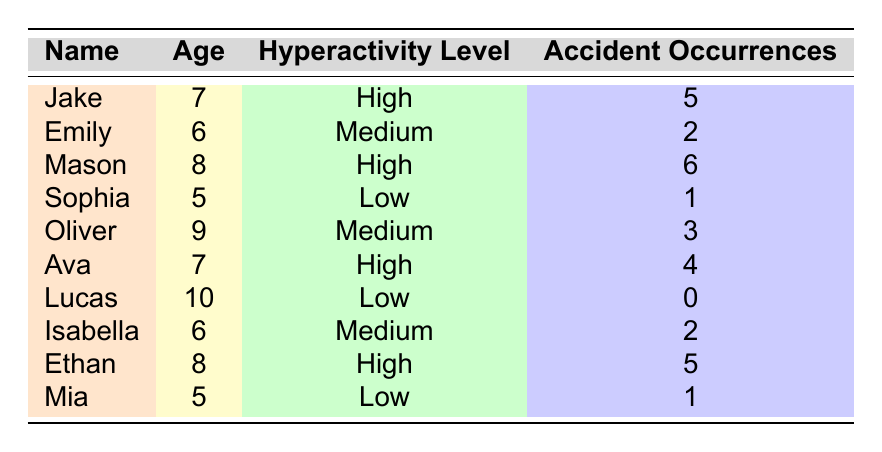What is the highest number of accident occurrences by a child in the table? The table shows the accident occurrences for each child. When looking at the values, Mason has the highest occurrence with 6 accidents.
Answer: 6 How many children have a high hyperactivity level? By checking the table, we see that Jake, Mason, and Ethan are the three children listed with a high hyperactivity level. Therefore, there are a total of 3 children with high hyperactivity.
Answer: 3 What is the accident occurrence of the child with the medium hyperactivity level who has the most accidents? From the table, we see that both Emily and Isabella have 2 accidents, while Oliver has 3 accidents. Since Oliver has the highest number of accidents in the medium hyperactivity level category, the answer is 3.
Answer: 3 What is the total number of accident occurrences for children with a low hyperactivity level? The children with a low hyperactivity level are Sophia, Lucas, and Mia. Their respective accident occurrences are 1, 0, and 1. Adding these values gives 1 + 0 + 1 = 2.
Answer: 2 Is there any child with a low hyperactivity level who has more than 2 accident occurrences? Checking the table, none of the children with a low hyperactivity level have more than 2 accident occurrences since their numbers are 1 (Sophia), 0 (Lucas), and 1 (Mia). Therefore, the answer is no.
Answer: No What is the average number of accident occurrences for children with a high hyperactivity level? The children with high hyperactivity are Jake (5), Mason (6), Ava (4), and Ethan (5). The total occurrences for these children is 5 + 6 + 4 + 5 = 20. There are 4 children, so the average is 20/4 = 5.
Answer: 5 Which child has the lowest accident occurrences and what is the level of their hyperactivity? The table indicates that Lucas has the lowest accident occurrences at 0 accidents. Lucas has a low hyperactivity level.
Answer: Lucas, Low How many kids aged 7 or younger have a high hyperactivity level? The relevant children aged 7 or younger with high hyperactivity level are Jake (7) and Ava (7). Thus, there are 2 children in this age bracket with high hyperactivity.
Answer: 2 What is the total number of accidents involving medium hyperactivity level children? The children with a medium hyperactivity level are Emily (2), Oliver (3), and Isabella (2). Adding these occurrences gives us 2 + 3 + 2 = 7.
Answer: 7 